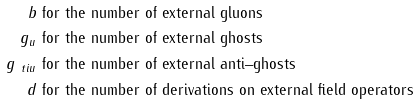Convert formula to latex. <formula><loc_0><loc_0><loc_500><loc_500>b & \text { for the number of external gluons} \\ g _ { u } & \text { for the number of external ghosts} \\ g _ { \ t i { u } } & \text { for the number of external anti--ghosts} \\ d & \text { for the number of derivations on external field operators}</formula> 